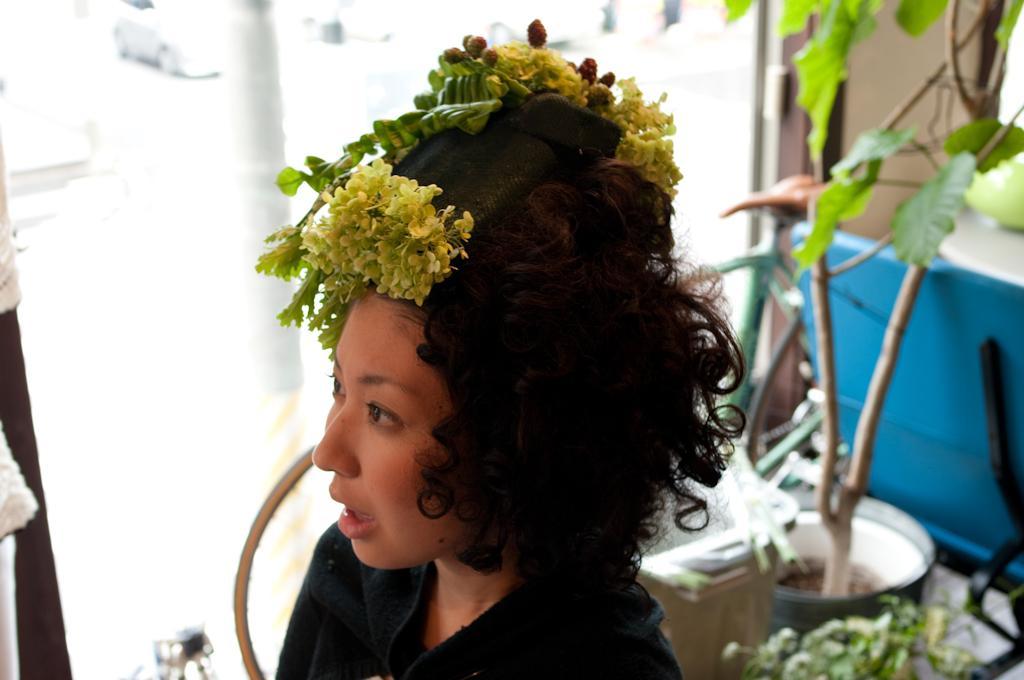How would you summarize this image in a sentence or two? In this image, we can see a person with some objects on her head. We can see the ground with some objects like plants. We can also see a blue colored object. We can see a pole and some glass. 